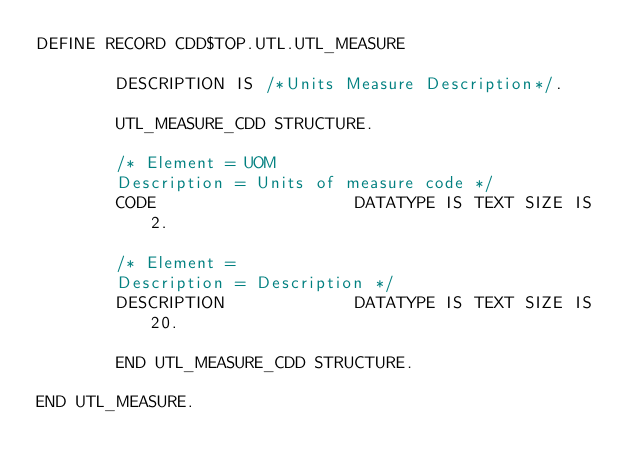<code> <loc_0><loc_0><loc_500><loc_500><_SQL_>DEFINE RECORD CDD$TOP.UTL.UTL_MEASURE

        DESCRIPTION IS /*Units Measure Description*/.

        UTL_MEASURE_CDD STRUCTURE.

        /* Element = UOM
        Description = Units of measure code */
        CODE                    DATATYPE IS TEXT SIZE IS 2.

        /* Element =
        Description = Description */
        DESCRIPTION             DATATYPE IS TEXT SIZE IS 20.

        END UTL_MEASURE_CDD STRUCTURE.

END UTL_MEASURE.
</code> 